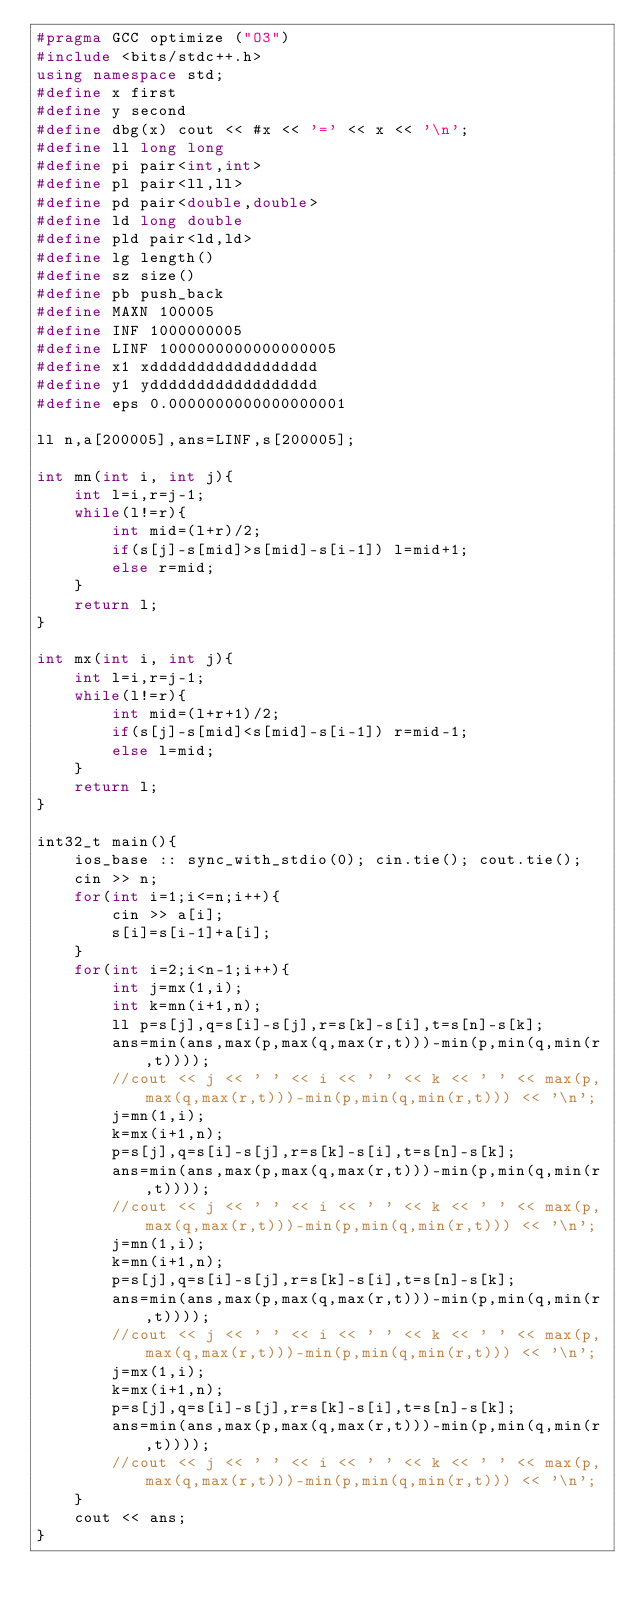<code> <loc_0><loc_0><loc_500><loc_500><_C++_>#pragma GCC optimize ("O3")
#include <bits/stdc++.h>
using namespace std;
#define x first
#define y second
#define dbg(x) cout << #x << '=' << x << '\n';
#define ll long long
#define pi pair<int,int>
#define pl pair<ll,ll>
#define pd pair<double,double>
#define ld long double
#define pld pair<ld,ld>
#define lg length()
#define sz size()
#define pb push_back
#define MAXN 100005
#define INF 1000000005
#define LINF 1000000000000000005
#define x1 xdddddddddddddddddd
#define y1 ydddddddddddddddddd
#define eps 0.0000000000000000001

ll n,a[200005],ans=LINF,s[200005];

int mn(int i, int j){
    int l=i,r=j-1;
    while(l!=r){
        int mid=(l+r)/2;
        if(s[j]-s[mid]>s[mid]-s[i-1]) l=mid+1;
        else r=mid;
    }
    return l;
}

int mx(int i, int j){
    int l=i,r=j-1;
    while(l!=r){
        int mid=(l+r+1)/2;
        if(s[j]-s[mid]<s[mid]-s[i-1]) r=mid-1;
        else l=mid;
    }
    return l;
}

int32_t main(){
    ios_base :: sync_with_stdio(0); cin.tie(); cout.tie();
    cin >> n;
    for(int i=1;i<=n;i++){
        cin >> a[i];
        s[i]=s[i-1]+a[i];
    }
    for(int i=2;i<n-1;i++){
        int j=mx(1,i);
        int k=mn(i+1,n);
        ll p=s[j],q=s[i]-s[j],r=s[k]-s[i],t=s[n]-s[k];
        ans=min(ans,max(p,max(q,max(r,t)))-min(p,min(q,min(r,t))));
        //cout << j << ' ' << i << ' ' << k << ' ' << max(p,max(q,max(r,t)))-min(p,min(q,min(r,t))) << '\n';
        j=mn(1,i);
        k=mx(i+1,n);
        p=s[j],q=s[i]-s[j],r=s[k]-s[i],t=s[n]-s[k];
        ans=min(ans,max(p,max(q,max(r,t)))-min(p,min(q,min(r,t))));
        //cout << j << ' ' << i << ' ' << k << ' ' << max(p,max(q,max(r,t)))-min(p,min(q,min(r,t))) << '\n';
        j=mn(1,i);
        k=mn(i+1,n);
        p=s[j],q=s[i]-s[j],r=s[k]-s[i],t=s[n]-s[k];
        ans=min(ans,max(p,max(q,max(r,t)))-min(p,min(q,min(r,t))));
        //cout << j << ' ' << i << ' ' << k << ' ' << max(p,max(q,max(r,t)))-min(p,min(q,min(r,t))) << '\n';
        j=mx(1,i);
        k=mx(i+1,n);
        p=s[j],q=s[i]-s[j],r=s[k]-s[i],t=s[n]-s[k];
        ans=min(ans,max(p,max(q,max(r,t)))-min(p,min(q,min(r,t))));
        //cout << j << ' ' << i << ' ' << k << ' ' << max(p,max(q,max(r,t)))-min(p,min(q,min(r,t))) << '\n';
    }
    cout << ans;
}
</code> 